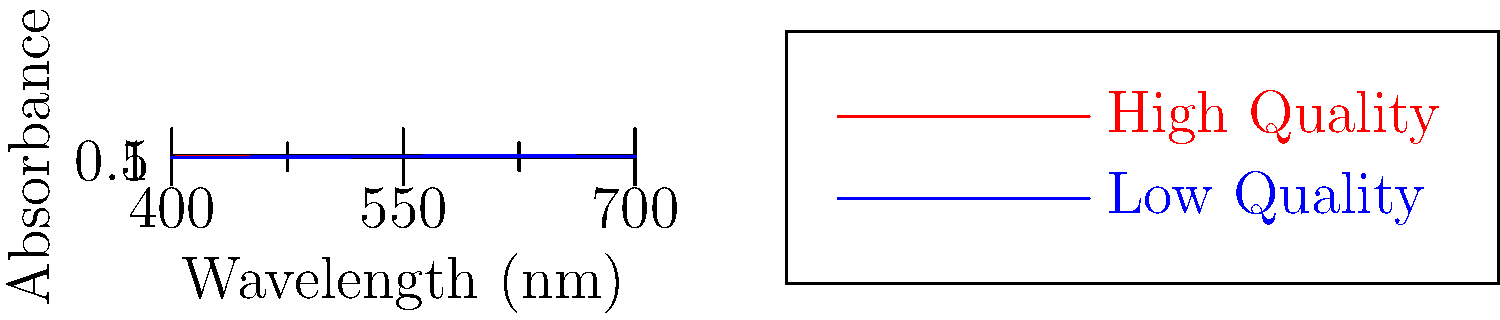Based on the spectral analysis graphs of wine samples shown above, which wavelength range shows the most significant difference between high-quality and low-quality wines, potentially allowing for efficient quality classification? To determine the wavelength range that shows the most significant difference between high-quality and low-quality wines, we need to analyze the graph step-by-step:

1. The graph shows absorbance values for different wavelengths (400-700 nm) for both high-quality (red line) and low-quality (blue line) wines.

2. We need to identify where the two lines have the greatest separation, as this indicates the most significant difference between the two qualities.

3. Examining the graph:
   - 400-500 nm: The lines are close together, showing little difference.
   - 500-550 nm: The lines begin to separate more noticeably.
   - 550-600 nm: The separation between the lines increases significantly.
   - 600-650 nm: The lines reach their maximum separation.
   - 650-700 nm: The lines begin to converge again.

4. The most significant difference is observed in the range of 550-600 nm, with the peak difference occurring around 600 nm.

5. This wavelength range (550-600 nm) corresponds to the yellow-orange part of the visible spectrum, which could be related to the color and phenolic compounds in the wine that contribute to its quality.

Therefore, the 550-600 nm range shows the most significant difference and would be most useful for efficiently classifying wine quality using spectral analysis.
Answer: 550-600 nm 